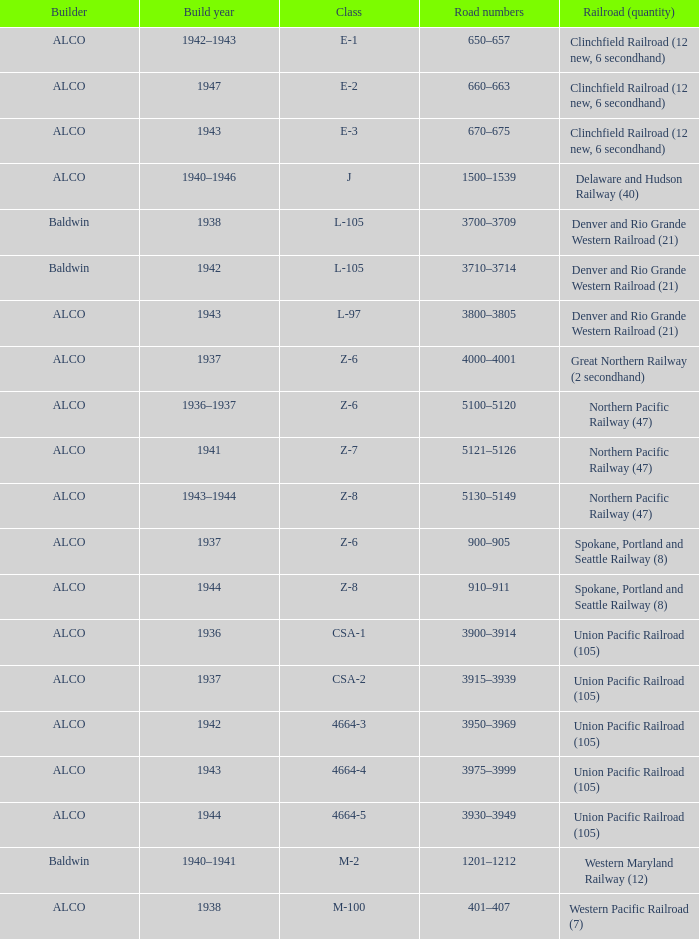What is the road numbers when the builder is alco, the railroad (quantity) is union pacific railroad (105) and the class is csa-2? 3915–3939. 